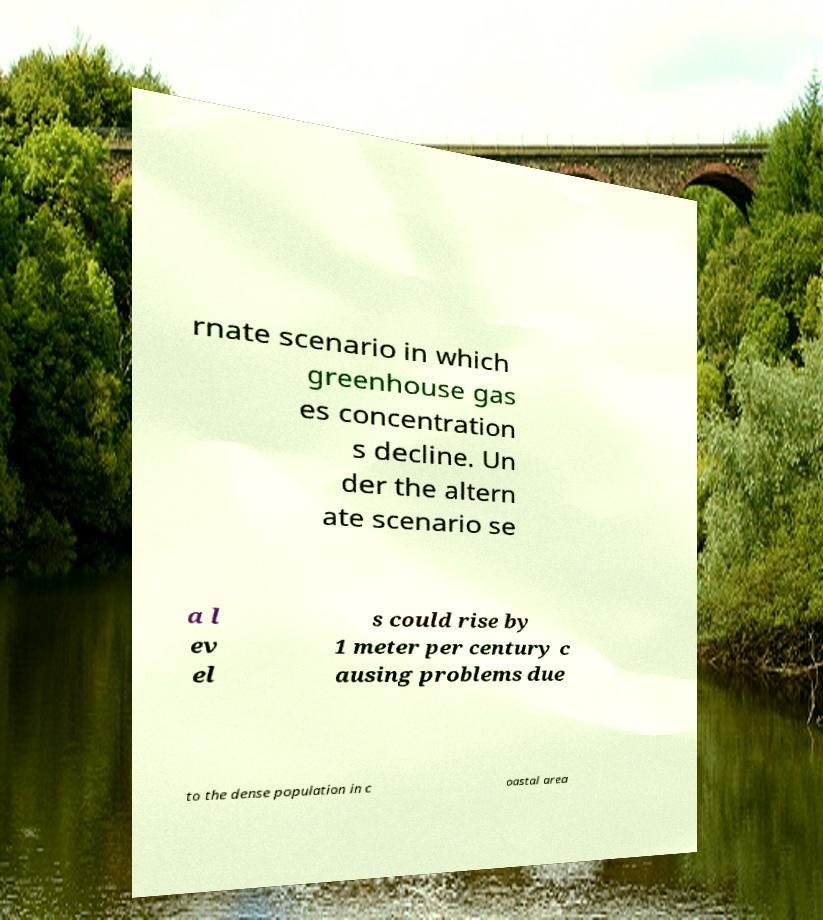Can you accurately transcribe the text from the provided image for me? rnate scenario in which greenhouse gas es concentration s decline. Un der the altern ate scenario se a l ev el s could rise by 1 meter per century c ausing problems due to the dense population in c oastal area 